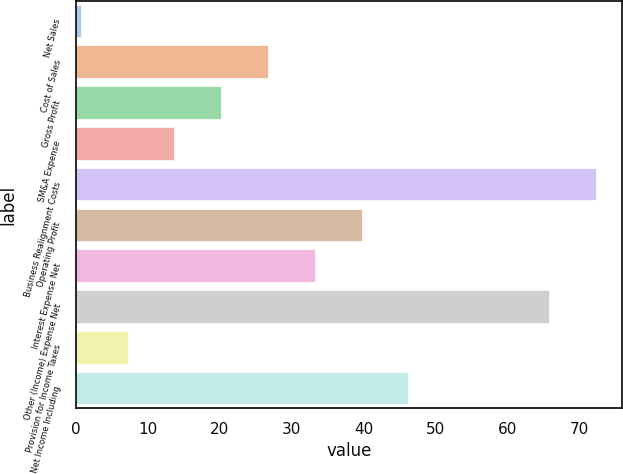Convert chart. <chart><loc_0><loc_0><loc_500><loc_500><bar_chart><fcel>Net Sales<fcel>Cost of Sales<fcel>Gross Profit<fcel>SM&A Expense<fcel>Business Realignment Costs<fcel>Operating Profit<fcel>Interest Expense Net<fcel>Other (Income) Expense Net<fcel>Provision for Income Taxes<fcel>Net Income Including<nl><fcel>0.7<fcel>26.7<fcel>20.2<fcel>13.7<fcel>72.2<fcel>39.7<fcel>33.2<fcel>65.7<fcel>7.2<fcel>46.2<nl></chart> 